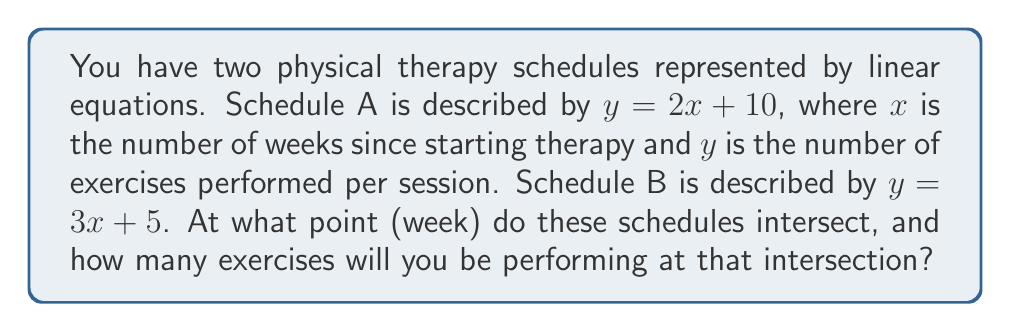Could you help me with this problem? To find the intersection point of these two schedules, we need to solve the system of equations:

$$\begin{cases}
y = 2x + 10 \\
y = 3x + 5
\end{cases}$$

1) Since both equations equal $y$, we can set them equal to each other:

   $2x + 10 = 3x + 5$

2) Subtract $2x$ from both sides:

   $10 = x + 5$

3) Subtract 5 from both sides:

   $5 = x$

4) Now that we know $x = 5$, we can substitute this back into either of the original equations to find $y$. Let's use the first equation:

   $y = 2(5) + 10$
   $y = 10 + 10 = 20$

5) Therefore, the schedules intersect at the point (5, 20).

This means the schedules intersect at week 5, and at that point, you will be performing 20 exercises per session.
Answer: Week 5, 20 exercises 